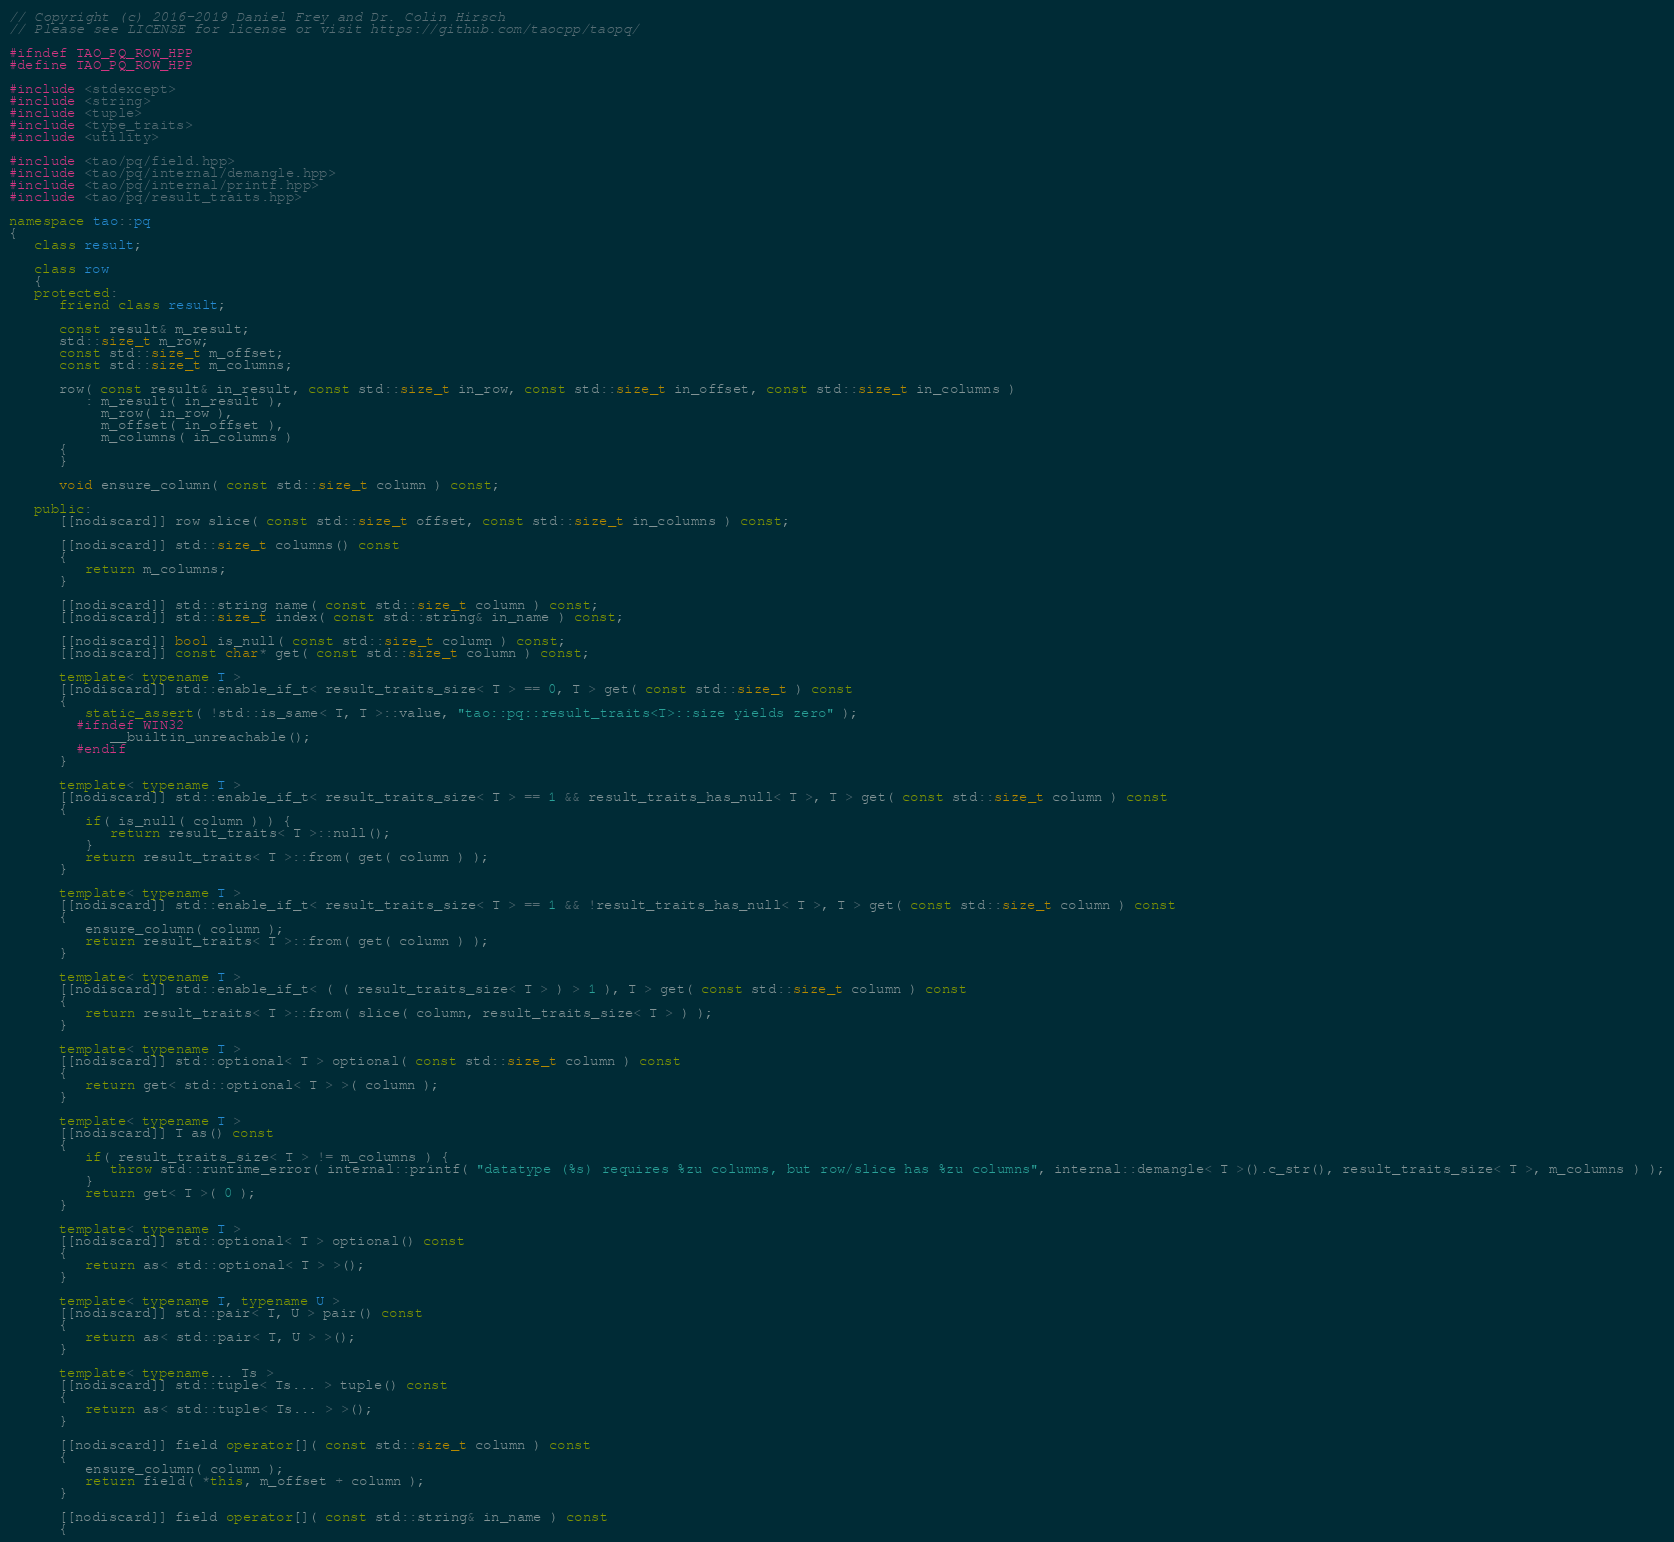<code> <loc_0><loc_0><loc_500><loc_500><_C++_>// Copyright (c) 2016-2019 Daniel Frey and Dr. Colin Hirsch
// Please see LICENSE for license or visit https://github.com/taocpp/taopq/

#ifndef TAO_PQ_ROW_HPP
#define TAO_PQ_ROW_HPP

#include <stdexcept>
#include <string>
#include <tuple>
#include <type_traits>
#include <utility>

#include <tao/pq/field.hpp>
#include <tao/pq/internal/demangle.hpp>
#include <tao/pq/internal/printf.hpp>
#include <tao/pq/result_traits.hpp>

namespace tao::pq
{
   class result;

   class row
   {
   protected:
      friend class result;

      const result& m_result;
      std::size_t m_row;
      const std::size_t m_offset;
      const std::size_t m_columns;

      row( const result& in_result, const std::size_t in_row, const std::size_t in_offset, const std::size_t in_columns )
         : m_result( in_result ),
           m_row( in_row ),
           m_offset( in_offset ),
           m_columns( in_columns )
      {
      }

      void ensure_column( const std::size_t column ) const;

   public:
      [[nodiscard]] row slice( const std::size_t offset, const std::size_t in_columns ) const;

      [[nodiscard]] std::size_t columns() const
      {
         return m_columns;
      }

      [[nodiscard]] std::string name( const std::size_t column ) const;
      [[nodiscard]] std::size_t index( const std::string& in_name ) const;

      [[nodiscard]] bool is_null( const std::size_t column ) const;
      [[nodiscard]] const char* get( const std::size_t column ) const;

      template< typename T >
      [[nodiscard]] std::enable_if_t< result_traits_size< T > == 0, T > get( const std::size_t ) const
      {
         static_assert( !std::is_same< T, T >::value, "tao::pq::result_traits<T>::size yields zero" );
		#ifndef WIN32
			__builtin_unreachable();
		#endif
      }

      template< typename T >
      [[nodiscard]] std::enable_if_t< result_traits_size< T > == 1 && result_traits_has_null< T >, T > get( const std::size_t column ) const
      {
         if( is_null( column ) ) {
            return result_traits< T >::null();
         }
         return result_traits< T >::from( get( column ) );
      }

      template< typename T >
      [[nodiscard]] std::enable_if_t< result_traits_size< T > == 1 && !result_traits_has_null< T >, T > get( const std::size_t column ) const
      {
         ensure_column( column );
         return result_traits< T >::from( get( column ) );
      }

      template< typename T >
      [[nodiscard]] std::enable_if_t< ( ( result_traits_size< T > ) > 1 ), T > get( const std::size_t column ) const
      {
         return result_traits< T >::from( slice( column, result_traits_size< T > ) );
      }

      template< typename T >
      [[nodiscard]] std::optional< T > optional( const std::size_t column ) const
      {
         return get< std::optional< T > >( column );
      }

      template< typename T >
      [[nodiscard]] T as() const
      {
         if( result_traits_size< T > != m_columns ) {
            throw std::runtime_error( internal::printf( "datatype (%s) requires %zu columns, but row/slice has %zu columns", internal::demangle< T >().c_str(), result_traits_size< T >, m_columns ) );
         }
         return get< T >( 0 );
      }

      template< typename T >
      [[nodiscard]] std::optional< T > optional() const
      {
         return as< std::optional< T > >();
      }

      template< typename T, typename U >
      [[nodiscard]] std::pair< T, U > pair() const
      {
         return as< std::pair< T, U > >();
      }

      template< typename... Ts >
      [[nodiscard]] std::tuple< Ts... > tuple() const
      {
         return as< std::tuple< Ts... > >();
      }

      [[nodiscard]] field operator[]( const std::size_t column ) const
      {
         ensure_column( column );
         return field( *this, m_offset + column );
      }

      [[nodiscard]] field operator[]( const std::string& in_name ) const
      {</code> 